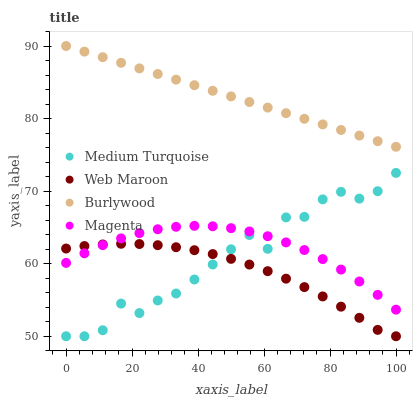Does Web Maroon have the minimum area under the curve?
Answer yes or no. Yes. Does Burlywood have the maximum area under the curve?
Answer yes or no. Yes. Does Magenta have the minimum area under the curve?
Answer yes or no. No. Does Magenta have the maximum area under the curve?
Answer yes or no. No. Is Burlywood the smoothest?
Answer yes or no. Yes. Is Medium Turquoise the roughest?
Answer yes or no. Yes. Is Magenta the smoothest?
Answer yes or no. No. Is Magenta the roughest?
Answer yes or no. No. Does Web Maroon have the lowest value?
Answer yes or no. Yes. Does Magenta have the lowest value?
Answer yes or no. No. Does Burlywood have the highest value?
Answer yes or no. Yes. Does Magenta have the highest value?
Answer yes or no. No. Is Web Maroon less than Burlywood?
Answer yes or no. Yes. Is Burlywood greater than Medium Turquoise?
Answer yes or no. Yes. Does Web Maroon intersect Magenta?
Answer yes or no. Yes. Is Web Maroon less than Magenta?
Answer yes or no. No. Is Web Maroon greater than Magenta?
Answer yes or no. No. Does Web Maroon intersect Burlywood?
Answer yes or no. No. 